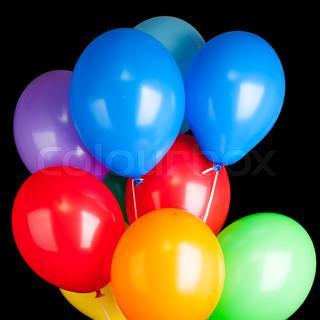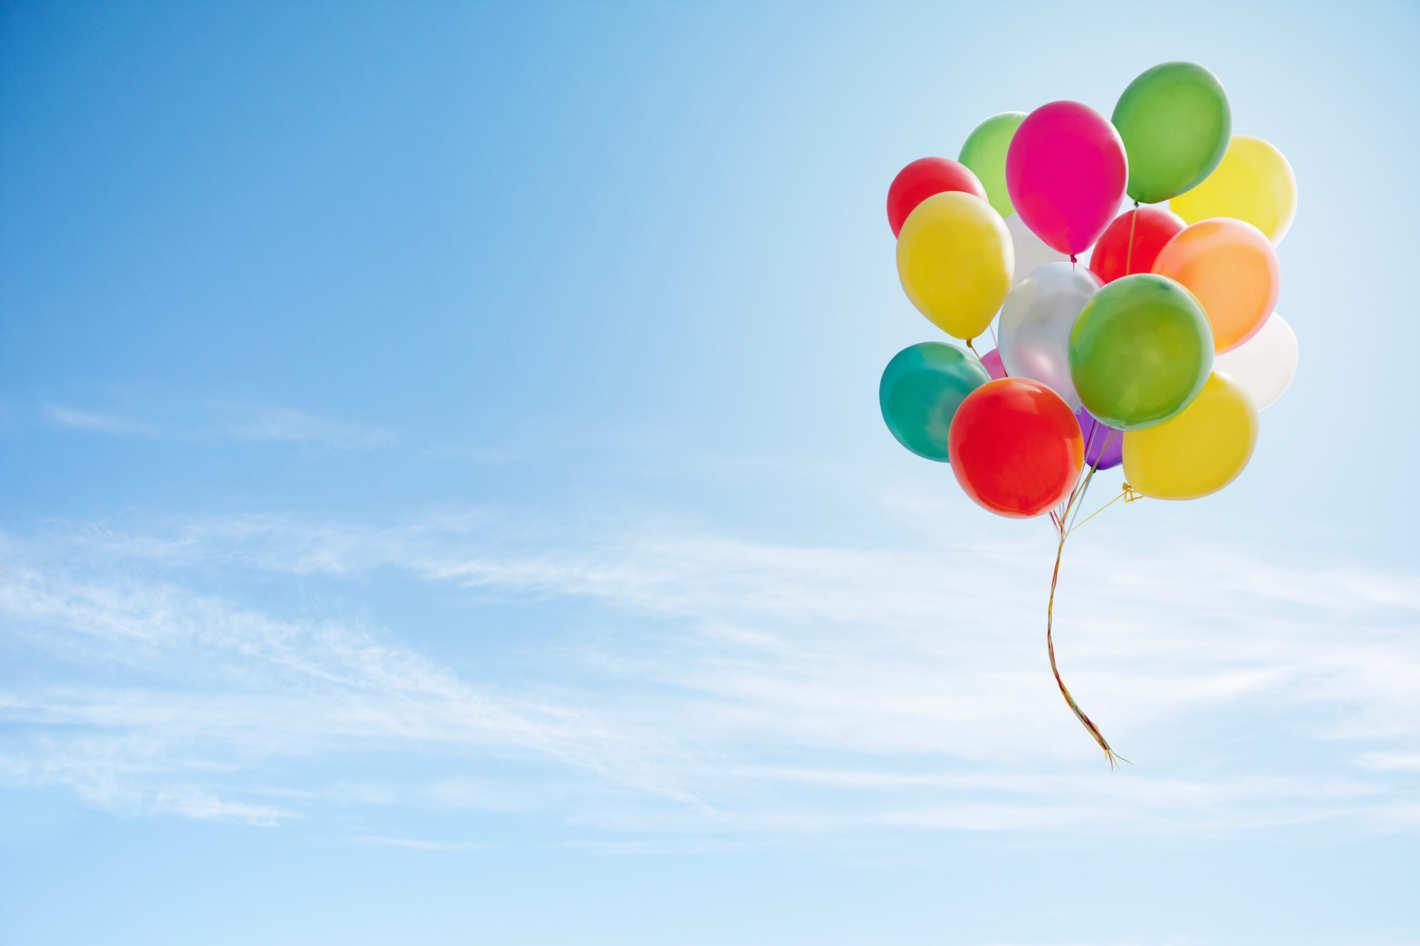The first image is the image on the left, the second image is the image on the right. Examine the images to the left and right. Is the description "Balloons are carrying an object up in the air." accurate? Answer yes or no. No. The first image is the image on the left, the second image is the image on the right. Evaluate the accuracy of this statement regarding the images: "There is at least one person holding balloons.". Is it true? Answer yes or no. No. 